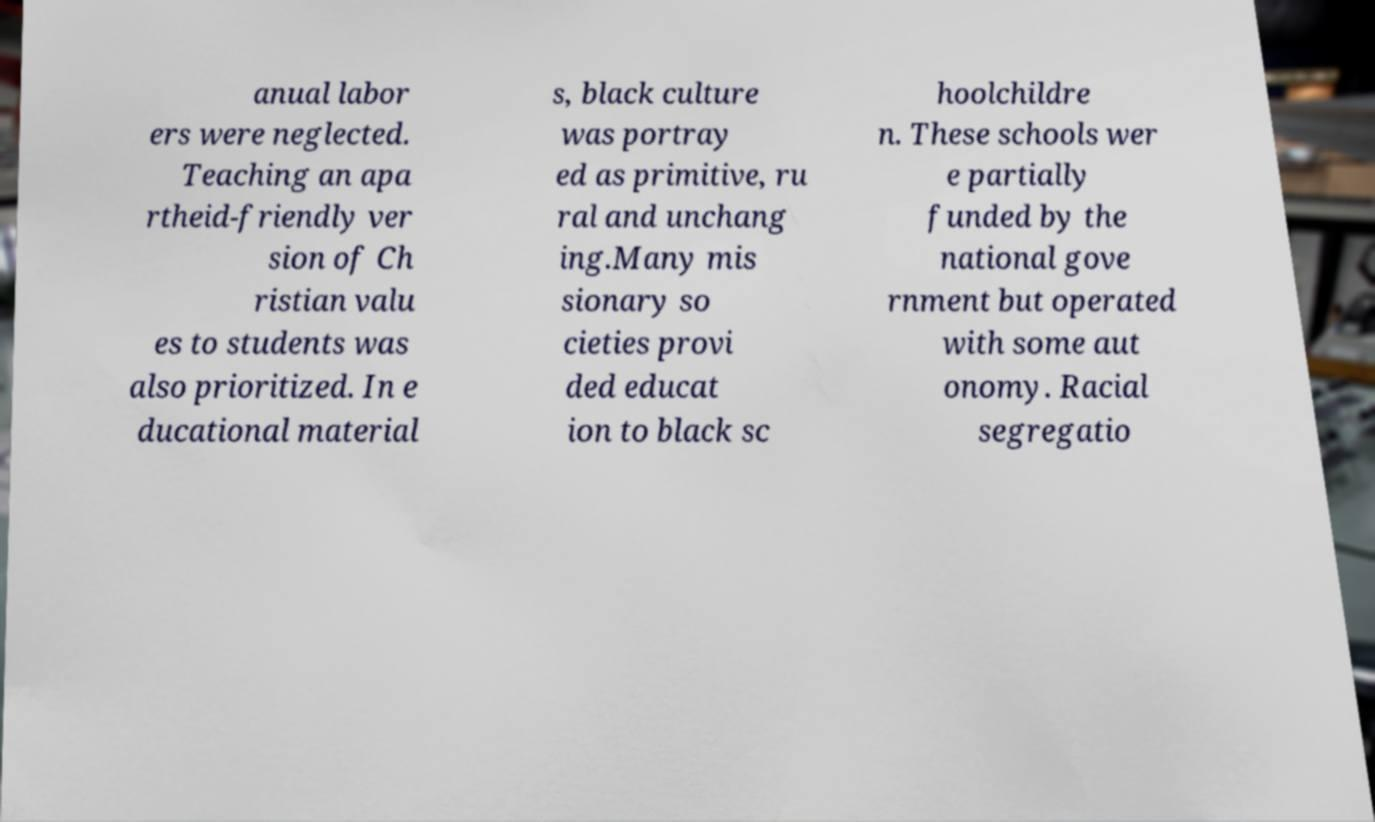Can you accurately transcribe the text from the provided image for me? anual labor ers were neglected. Teaching an apa rtheid-friendly ver sion of Ch ristian valu es to students was also prioritized. In e ducational material s, black culture was portray ed as primitive, ru ral and unchang ing.Many mis sionary so cieties provi ded educat ion to black sc hoolchildre n. These schools wer e partially funded by the national gove rnment but operated with some aut onomy. Racial segregatio 